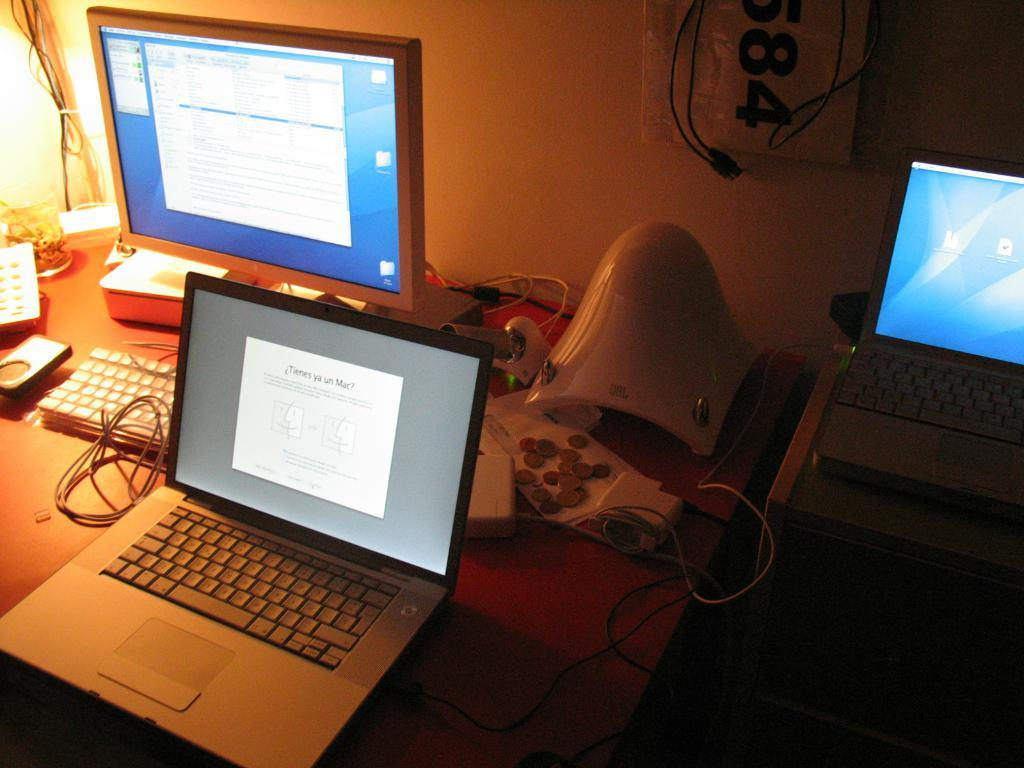What type of table is in the image? There is a wooden table in the image. What electronic devices are on the table? A computer with a keyboard, a laptop, and another laptop are on the table. What is used to provide additional power outlets for the devices? An electrical extension box is on the table. What type of government is represented by the bulb in the image? There is no bulb present in the image, and therefore no government can be associated with it. 